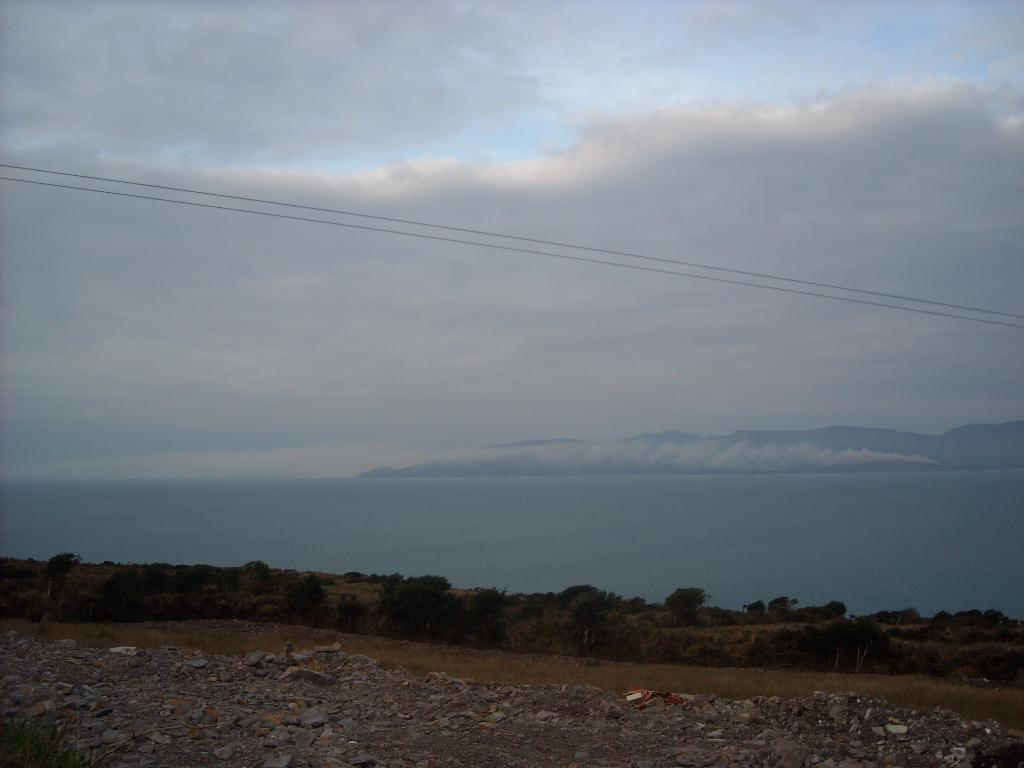What is located at the bottom of the image? There are stones and objects at the bottom of the image. What type of vegetation can be seen in the image? There are trees and plants in the image. What is visible in the background of the image? Water, hills, and a cloudy sky are visible in the background of the image. Are there any man-made structures in the image? Yes, there are wires in the image. Can you tell me how many zebras are grazing in the image? There are no zebras present in the image. What type of lumber is being used to construct the trees in the image? The trees in the image are natural, and there is no mention of lumber being used. 